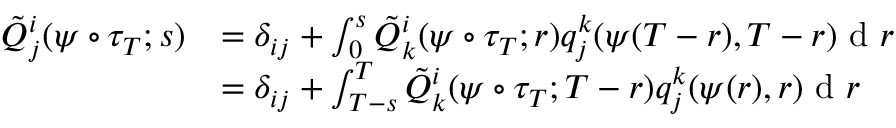Convert formula to latex. <formula><loc_0><loc_0><loc_500><loc_500>\begin{array} { r l } { \tilde { Q } _ { j } ^ { i } ( \psi \circ \tau _ { T } ; s ) } & { = \delta _ { i j } + \int _ { 0 } ^ { s } \tilde { Q } _ { k } ^ { i } ( \psi \circ \tau _ { T } ; r ) q _ { j } ^ { k } ( \psi ( T - r ) , T - r ) d r } \\ & { = \delta _ { i j } + \int _ { T - s } ^ { T } \tilde { Q } _ { k } ^ { i } ( \psi \circ \tau _ { T } ; T - r ) q _ { j } ^ { k } ( \psi ( r ) , r ) d r } \end{array}</formula> 